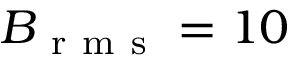Convert formula to latex. <formula><loc_0><loc_0><loc_500><loc_500>B _ { r m s } = 1 0</formula> 